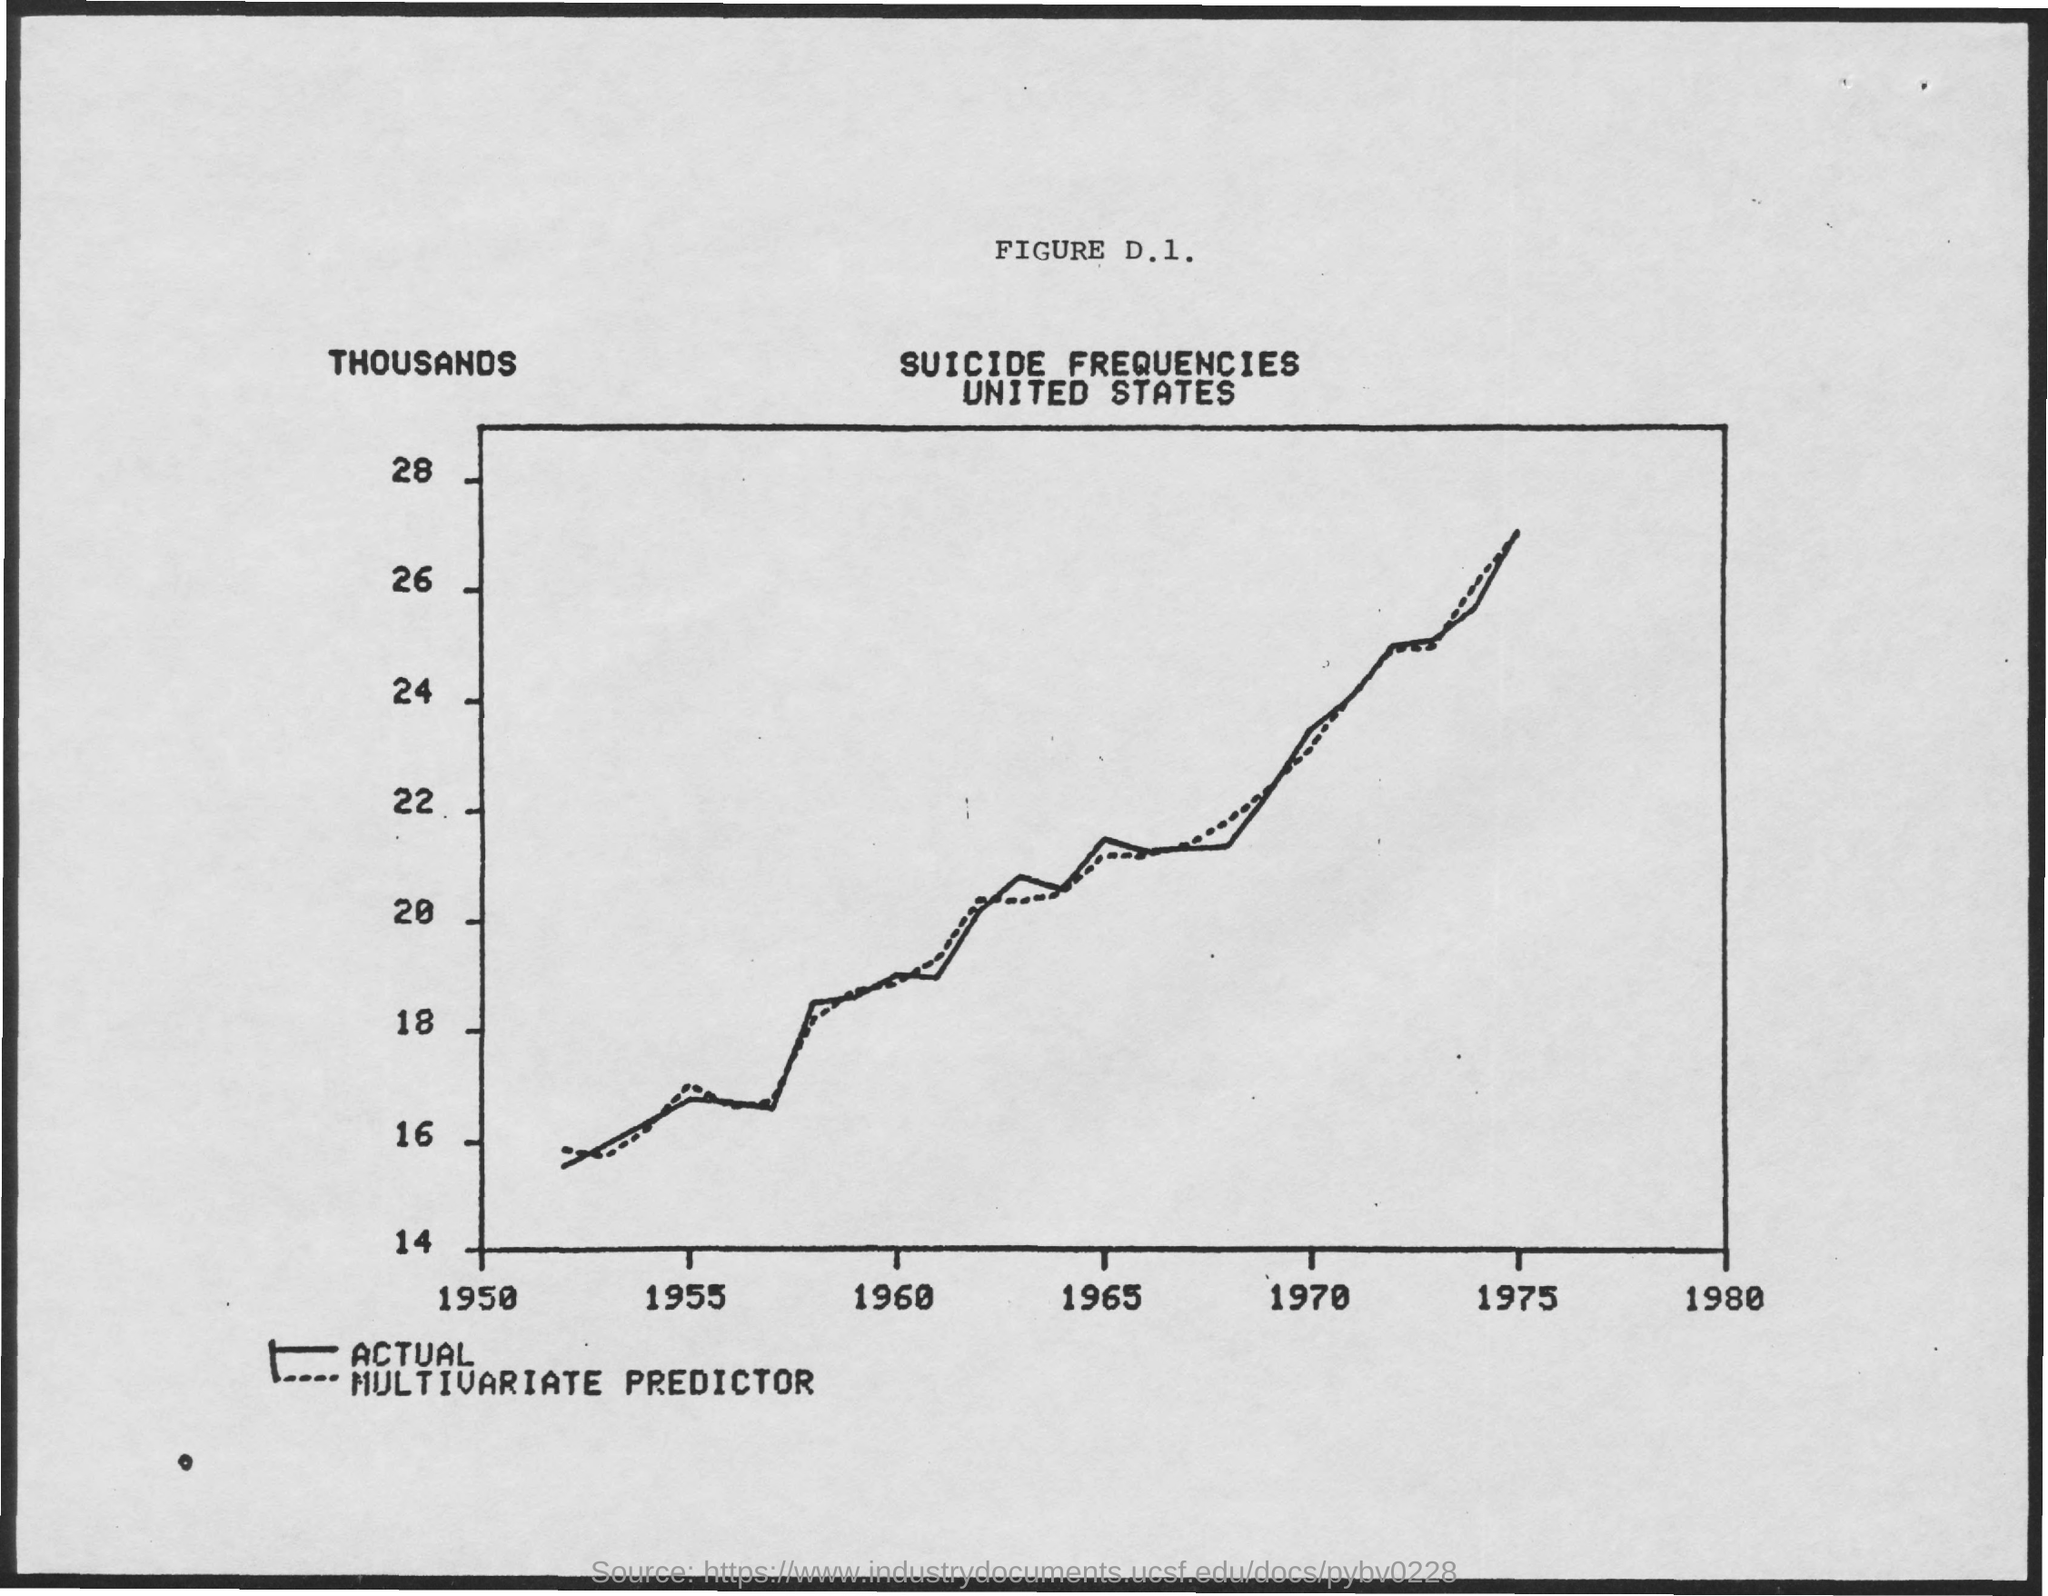Give some essential details in this illustration. What is the graph title? Suicide frequencies in the United States. 